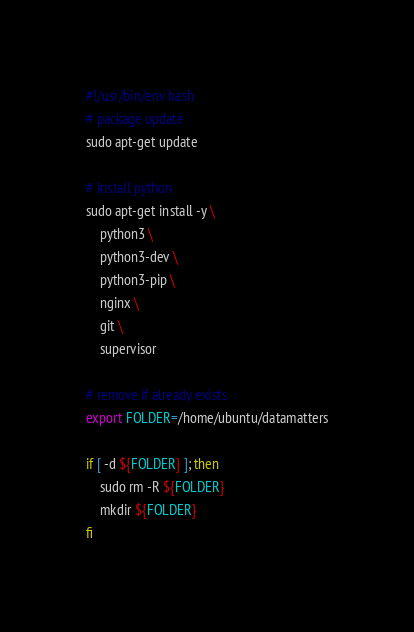<code> <loc_0><loc_0><loc_500><loc_500><_Bash_>#!/usr/bin/env bash
# package update
sudo apt-get update

# install python
sudo apt-get install -y \
    python3 \
    python3-dev \
    python3-pip \
    nginx \
    git \
    supervisor

# remove if already exists
export FOLDER=/home/ubuntu/datamatters

if [ -d ${FOLDER} ]; then
    sudo rm -R ${FOLDER}
    mkdir ${FOLDER}
fi

</code> 